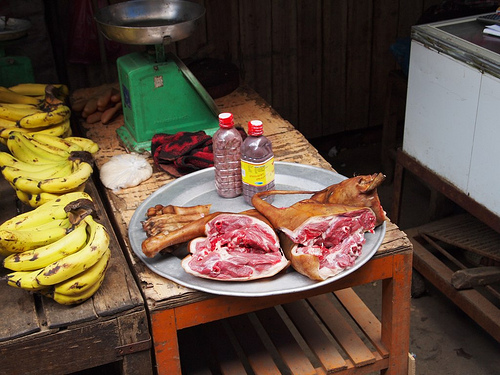<image>
Is the meat on the scale? No. The meat is not positioned on the scale. They may be near each other, but the meat is not supported by or resting on top of the scale. 